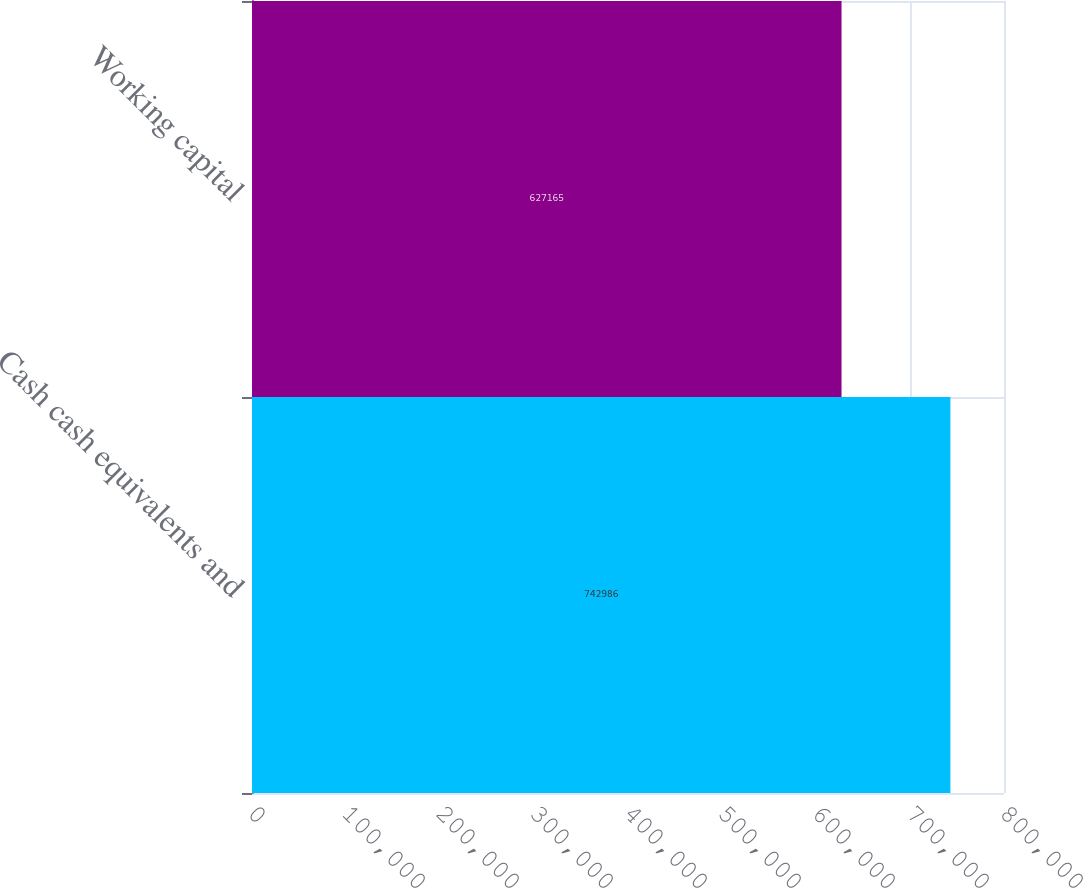Convert chart to OTSL. <chart><loc_0><loc_0><loc_500><loc_500><bar_chart><fcel>Cash cash equivalents and<fcel>Working capital<nl><fcel>742986<fcel>627165<nl></chart> 